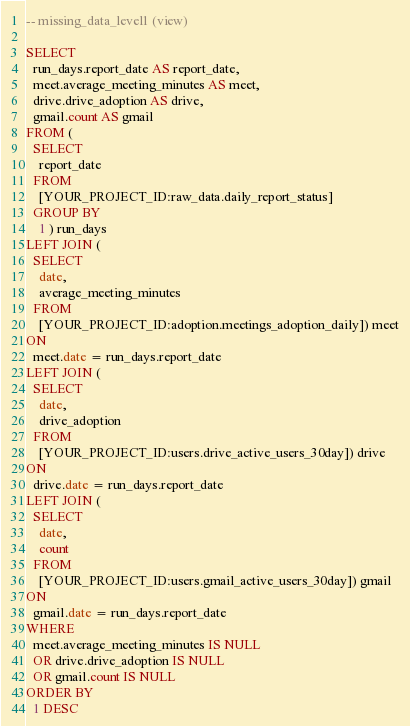<code> <loc_0><loc_0><loc_500><loc_500><_SQL_>-- missing_data_level1 (view)

SELECT
  run_days.report_date AS report_date,
  meet.average_meeting_minutes AS meet,
  drive.drive_adoption AS drive,
  gmail.count AS gmail
FROM (
  SELECT
    report_date
  FROM
    [YOUR_PROJECT_ID:raw_data.daily_report_status]
  GROUP BY
    1 ) run_days
LEFT JOIN (
  SELECT
    date,
    average_meeting_minutes
  FROM
    [YOUR_PROJECT_ID:adoption.meetings_adoption_daily]) meet
ON
  meet.date = run_days.report_date
LEFT JOIN (
  SELECT
    date,
    drive_adoption
  FROM
    [YOUR_PROJECT_ID:users.drive_active_users_30day]) drive
ON
  drive.date = run_days.report_date
LEFT JOIN (
  SELECT
    date,
    count
  FROM
    [YOUR_PROJECT_ID:users.gmail_active_users_30day]) gmail
ON
  gmail.date = run_days.report_date
WHERE
  meet.average_meeting_minutes IS NULL
  OR drive.drive_adoption IS NULL
  OR gmail.count IS NULL
ORDER BY
  1 DESC</code> 